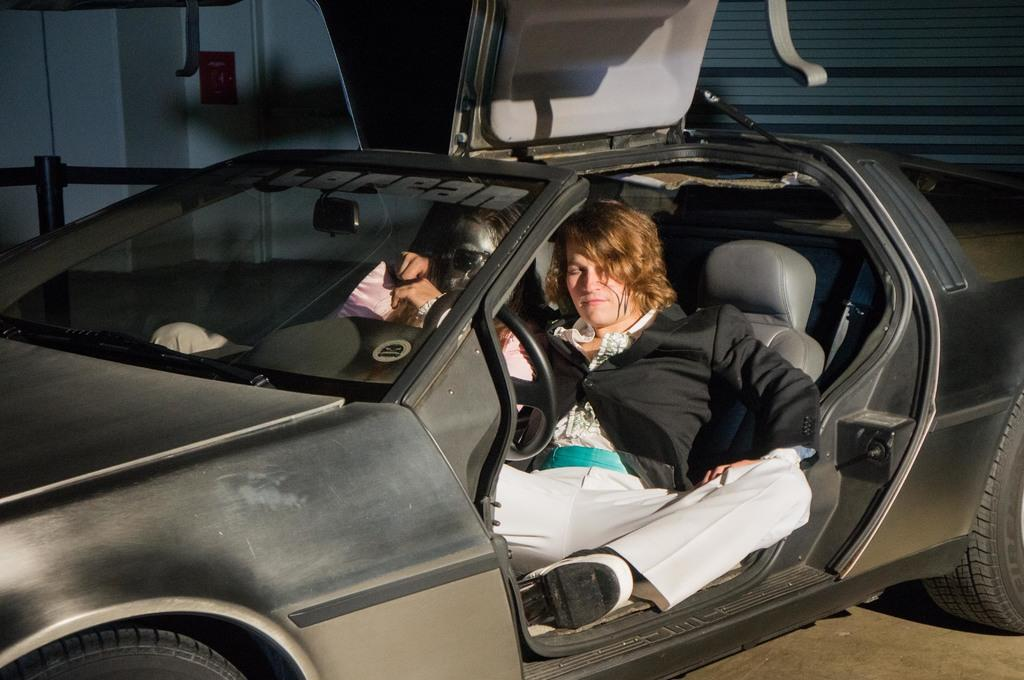How many people are in the car in the image? There are two persons sitting in the car. Where is the car located in the image? The car is in the center of the image. What can be seen in the background of the image? There is a wall in the background of the image. What part of the car is visible in the image? The car is shown from the side, with the front and back partially visible. What type of knife is being used by the person in the car? There is no knife present in the image; it only shows two people sitting in a car. 